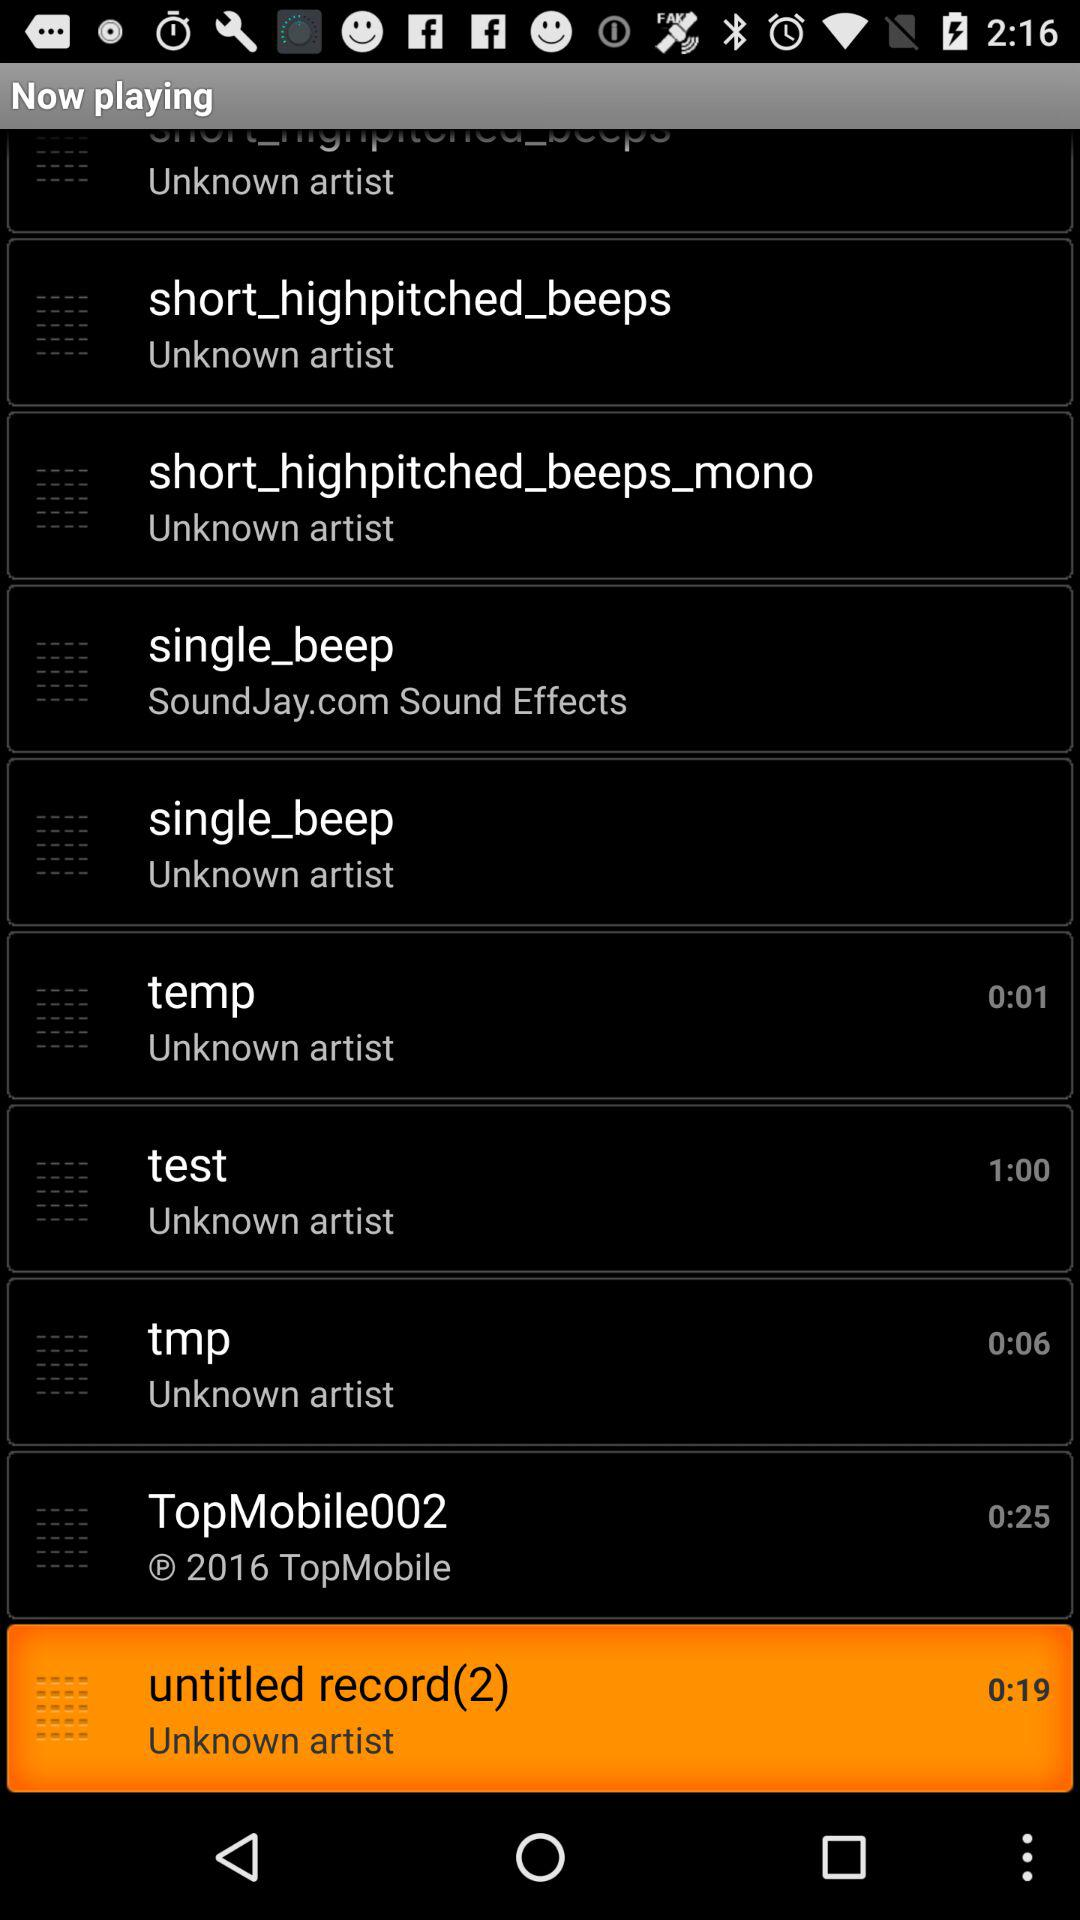What's the duration of "test"? The duration of "test" is 1 minute. 